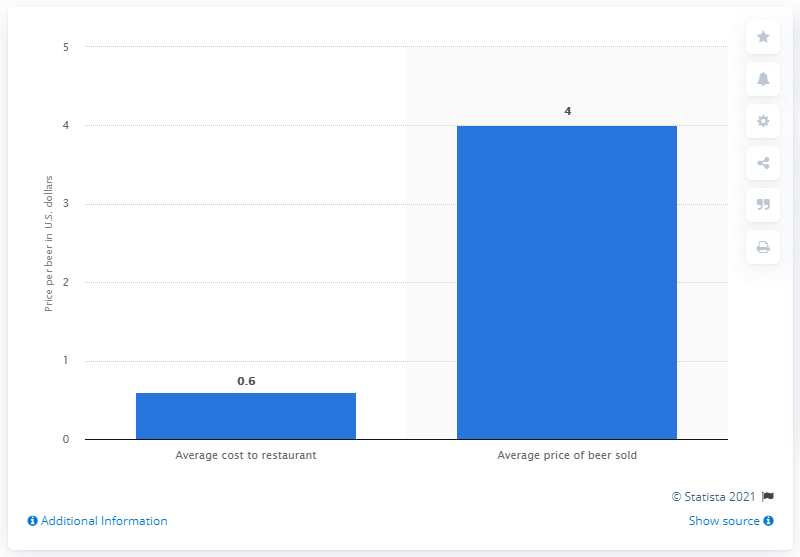Indicate a few pertinent items in this graphic. In 2013, the average cost of a beer ordered from restaurants in the United States was approximately 0.6 dollars. 